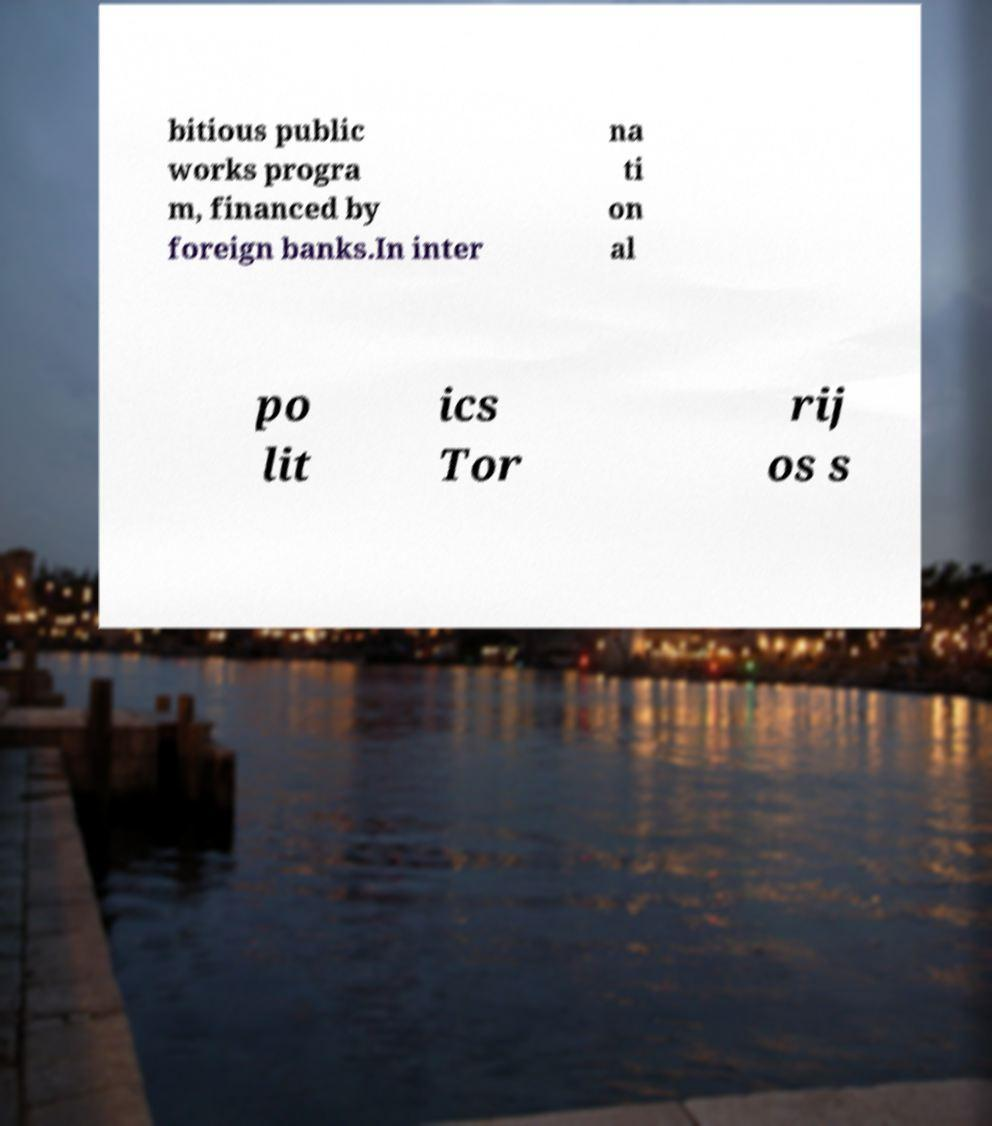For documentation purposes, I need the text within this image transcribed. Could you provide that? bitious public works progra m, financed by foreign banks.In inter na ti on al po lit ics Tor rij os s 